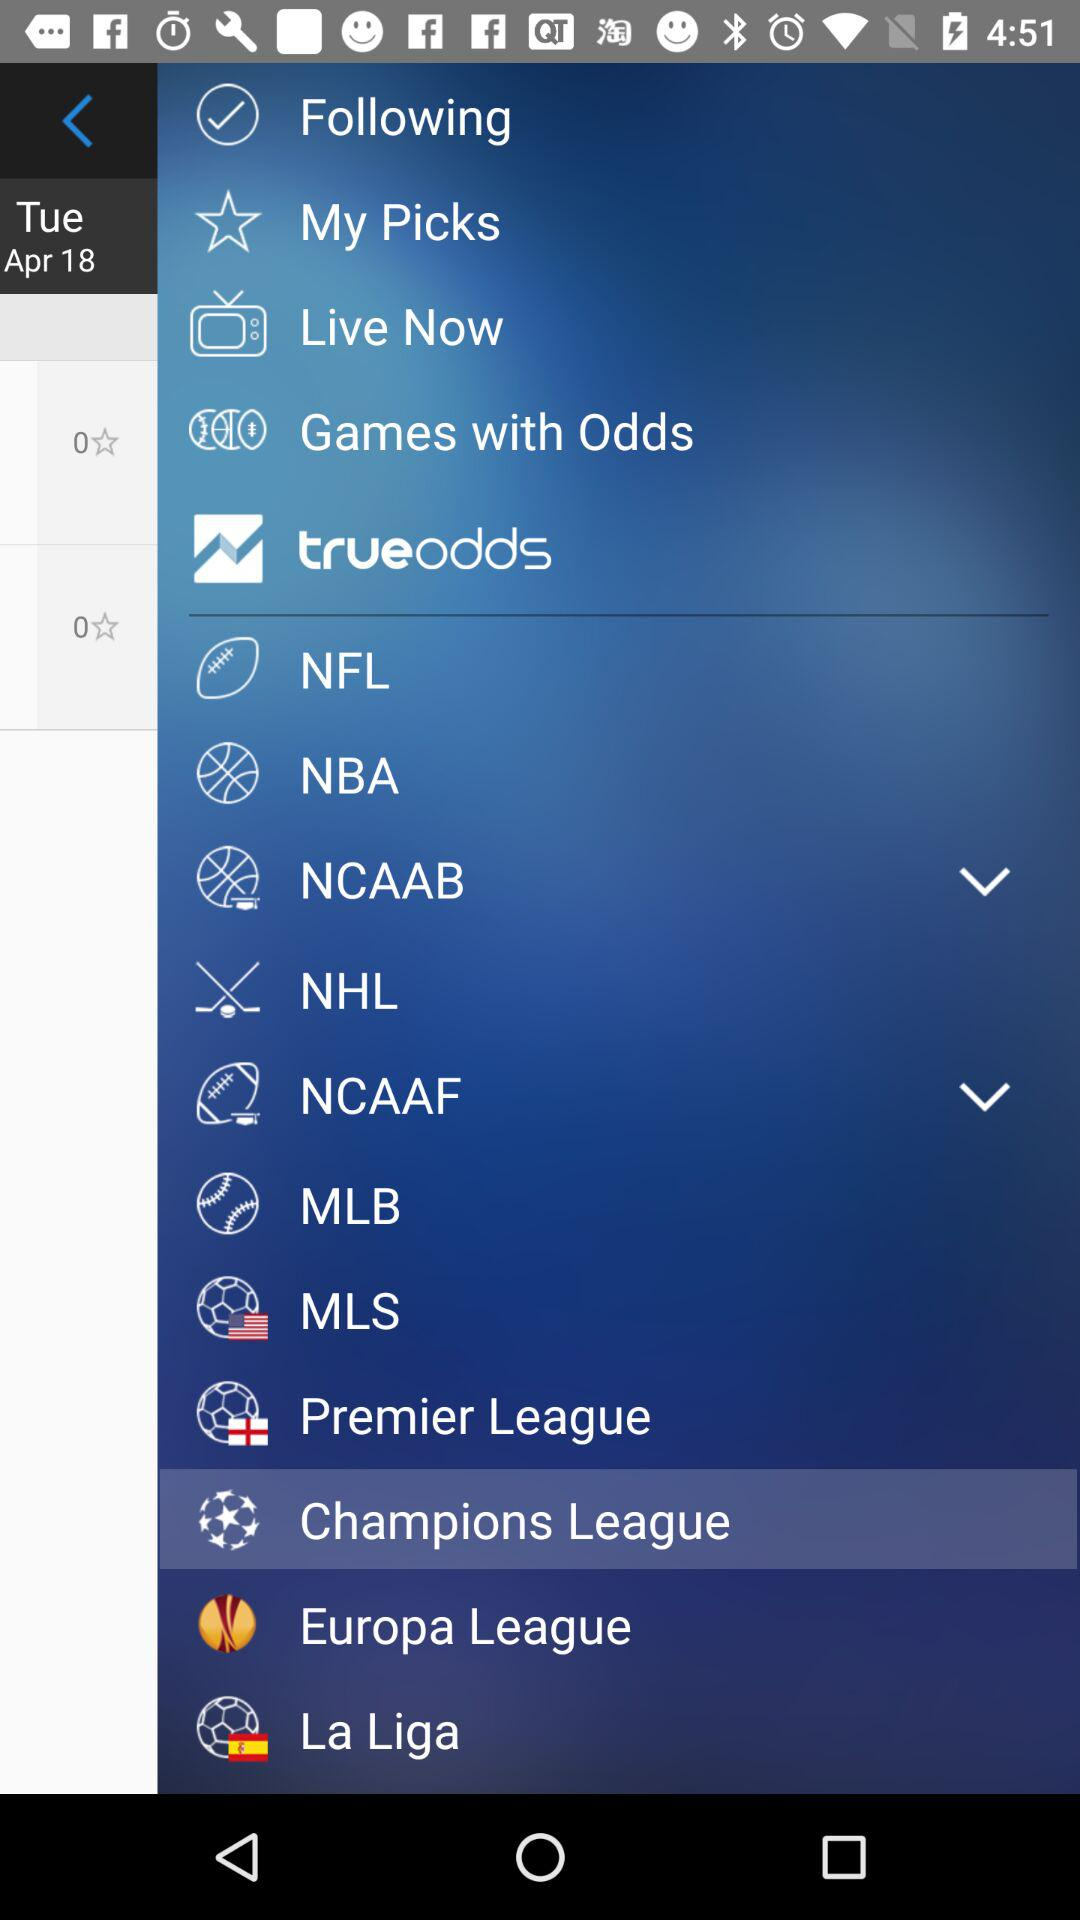What is the day on the given date? The day on the given date is Tuesday. 